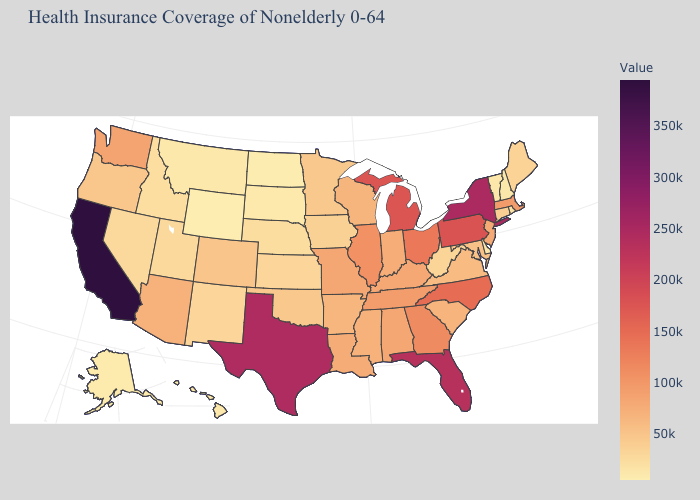Among the states that border California , which have the highest value?
Keep it brief. Arizona. Does Oklahoma have a lower value than Alaska?
Quick response, please. No. Among the states that border New Mexico , does Utah have the lowest value?
Be succinct. Yes. Is the legend a continuous bar?
Keep it brief. Yes. Among the states that border Michigan , which have the lowest value?
Write a very short answer. Wisconsin. Among the states that border Louisiana , which have the highest value?
Answer briefly. Texas. 